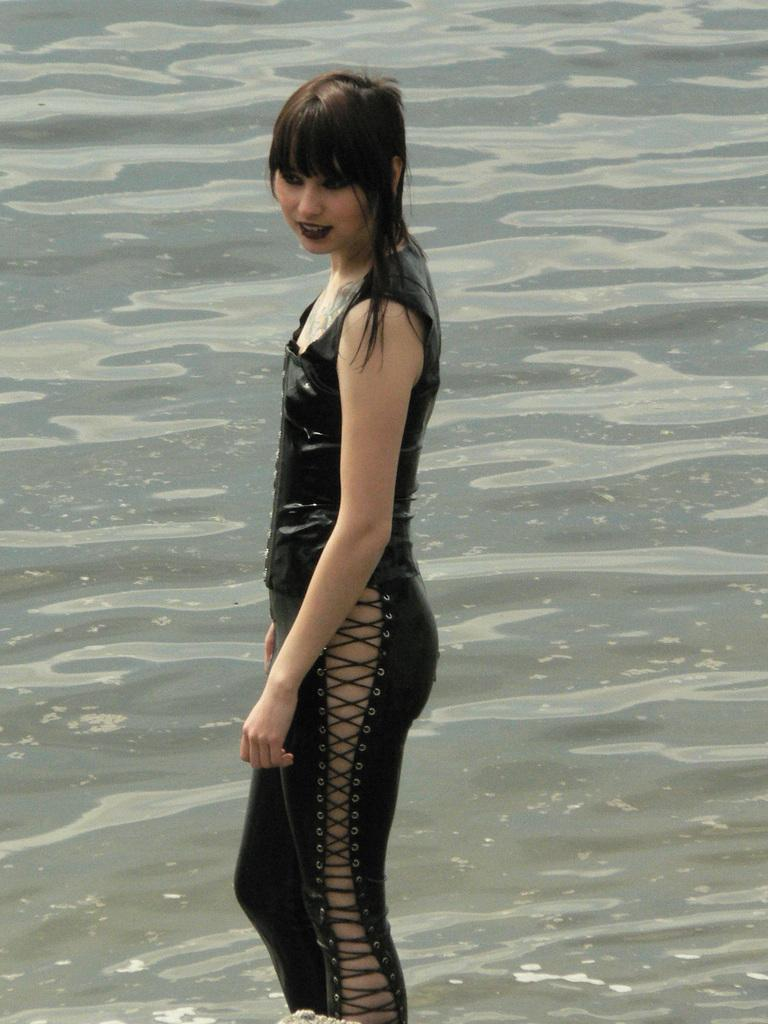What is present in the image that is not a person or clothing? There is water in the image. Can you describe the woman in the image? The woman in the image is wearing a black dress. What type of book is the woman holding in the image? There is no book present in the image; the woman is not holding anything. 